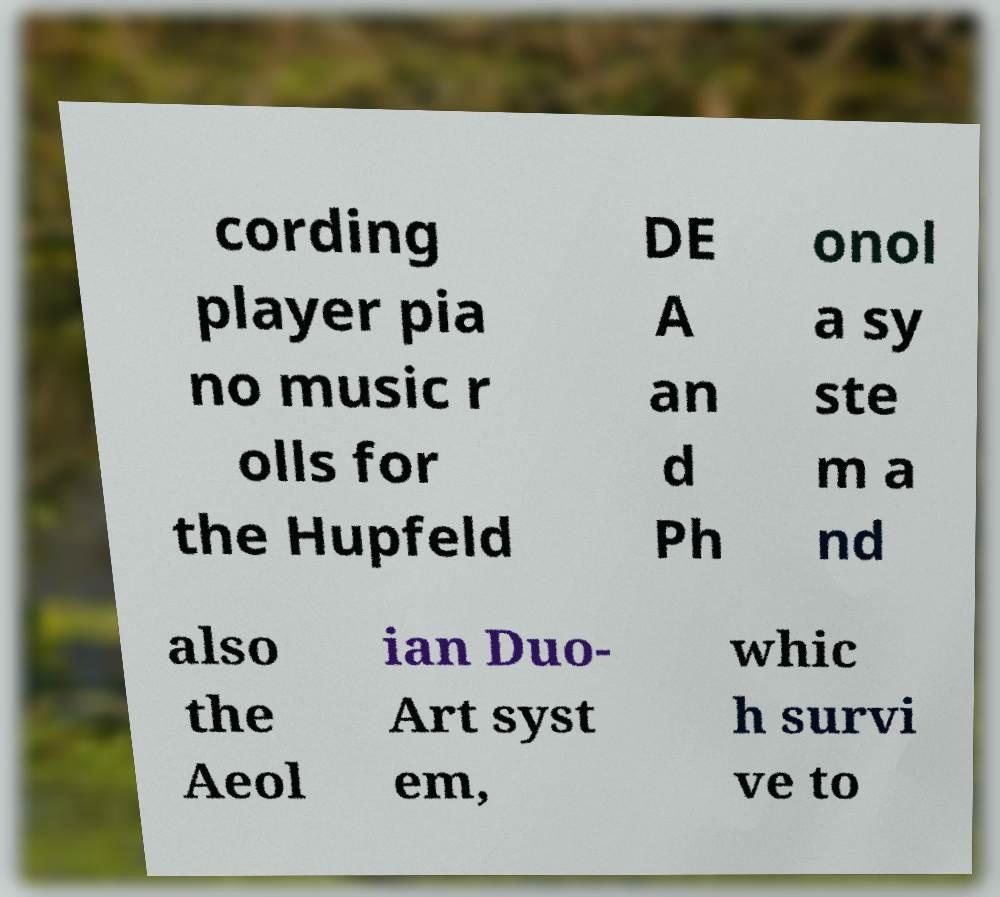Can you accurately transcribe the text from the provided image for me? cording player pia no music r olls for the Hupfeld DE A an d Ph onol a sy ste m a nd also the Aeol ian Duo- Art syst em, whic h survi ve to 